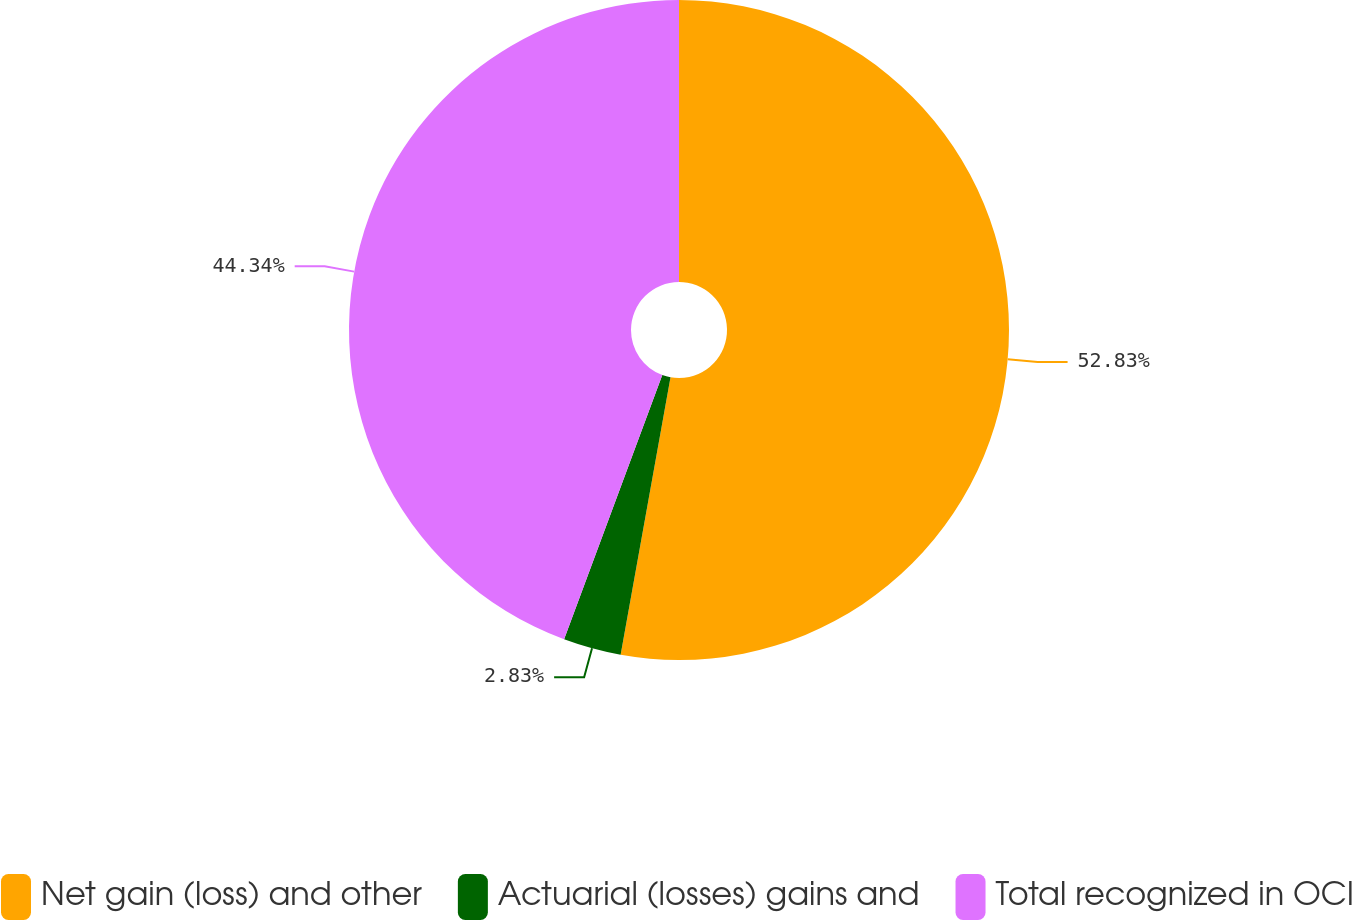Convert chart to OTSL. <chart><loc_0><loc_0><loc_500><loc_500><pie_chart><fcel>Net gain (loss) and other<fcel>Actuarial (losses) gains and<fcel>Total recognized in OCI<nl><fcel>52.83%<fcel>2.83%<fcel>44.34%<nl></chart> 